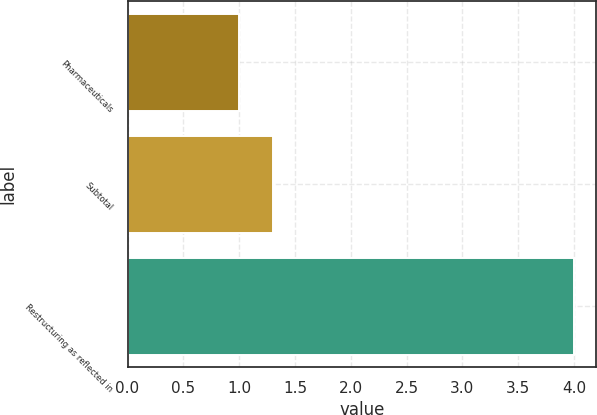<chart> <loc_0><loc_0><loc_500><loc_500><bar_chart><fcel>Pharmaceuticals<fcel>Subtotal<fcel>Restructuring as reflected in<nl><fcel>1<fcel>1.3<fcel>4<nl></chart> 